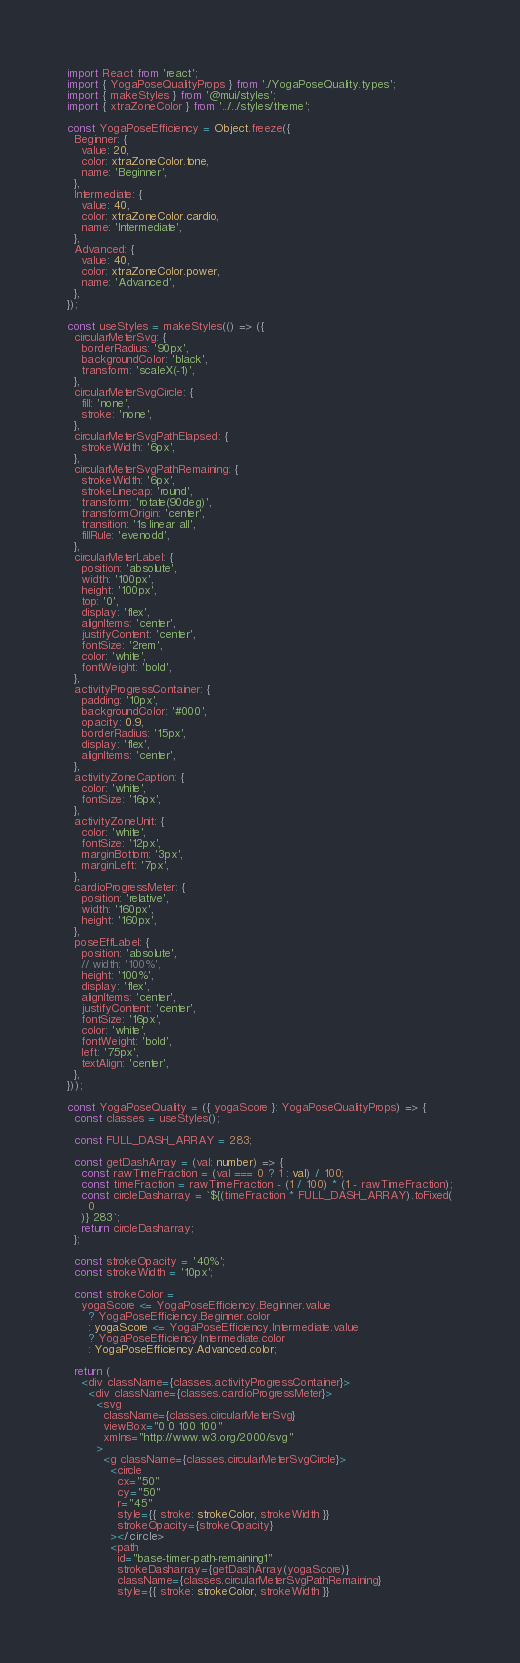Convert code to text. <code><loc_0><loc_0><loc_500><loc_500><_TypeScript_>import React from 'react';
import { YogaPoseQualityProps } from './YogaPoseQuality.types';
import { makeStyles } from '@mui/styles';
import { xtraZoneColor } from '../../styles/theme';

const YogaPoseEfficiency = Object.freeze({
  Beginner: {
    value: 20,
    color: xtraZoneColor.tone,
    name: 'Beginner',
  },
  Intermediate: {
    value: 40,
    color: xtraZoneColor.cardio,
    name: 'Intermediate',
  },
  Advanced: {
    value: 40,
    color: xtraZoneColor.power,
    name: 'Advanced',
  },
});

const useStyles = makeStyles(() => ({
  circularMeterSvg: {
    borderRadius: '90px',
    backgroundColor: 'black',
    transform: 'scaleX(-1)',
  },
  circularMeterSvgCircle: {
    fill: 'none',
    stroke: 'none',
  },
  circularMeterSvgPathElapsed: {
    strokeWidth: '6px',
  },
  circularMeterSvgPathRemaining: {
    strokeWidth: '6px',
    strokeLinecap: 'round',
    transform: 'rotate(90deg)',
    transformOrigin: 'center',
    transition: '1s linear all',
    fillRule: 'evenodd',
  },
  circularMeterLabel: {
    position: 'absolute',
    width: '100px',
    height: '100px',
    top: '0',
    display: 'flex',
    alignItems: 'center',
    justifyContent: 'center',
    fontSize: '2rem',
    color: 'white',
    fontWeight: 'bold',
  },
  activityProgressContainer: {
    padding: '10px',
    backgroundColor: '#000',
    opacity: 0.9,
    borderRadius: '15px',
    display: 'flex',
    alignItems: 'center',
  },
  activityZoneCaption: {
    color: 'white',
    fontSize: '16px',
  },
  activityZoneUnit: {
    color: 'white',
    fontSize: '12px',
    marginBottom: '3px',
    marginLeft: '7px',
  },
  cardioProgressMeter: {
    position: 'relative',
    width: '160px',
    height: '160px',
  },
  poseEffLabel: {
    position: 'absolute',
    // width: '100%',
    height: '100%',
    display: 'flex',
    alignItems: 'center',
    justifyContent: 'center',
    fontSize: '16px',
    color: 'white',
    fontWeight: 'bold',
    left: '75px',
    textAlign: 'center',
  },
}));

const YogaPoseQuality = ({ yogaScore }: YogaPoseQualityProps) => {
  const classes = useStyles();

  const FULL_DASH_ARRAY = 283;

  const getDashArray = (val: number) => {
    const rawTimeFraction = (val === 0 ? 1 : val) / 100;
    const timeFraction = rawTimeFraction - (1 / 100) * (1 - rawTimeFraction);
    const circleDasharray = `${(timeFraction * FULL_DASH_ARRAY).toFixed(
      0
    )} 283`;
    return circleDasharray;
  };

  const strokeOpacity = '40%';
  const strokeWidth = '10px';

  const strokeColor =
    yogaScore <= YogaPoseEfficiency.Beginner.value
      ? YogaPoseEfficiency.Beginner.color
      : yogaScore <= YogaPoseEfficiency.Intermediate.value
      ? YogaPoseEfficiency.Intermediate.color
      : YogaPoseEfficiency.Advanced.color;

  return (
    <div className={classes.activityProgressContainer}>
      <div className={classes.cardioProgressMeter}>
        <svg
          className={classes.circularMeterSvg}
          viewBox="0 0 100 100"
          xmlns="http://www.w3.org/2000/svg"
        >
          <g className={classes.circularMeterSvgCircle}>
            <circle
              cx="50"
              cy="50"
              r="45"
              style={{ stroke: strokeColor, strokeWidth }}
              strokeOpacity={strokeOpacity}
            ></circle>
            <path
              id="base-timer-path-remaining1"
              strokeDasharray={getDashArray(yogaScore)}
              className={classes.circularMeterSvgPathRemaining}
              style={{ stroke: strokeColor, strokeWidth }}</code> 